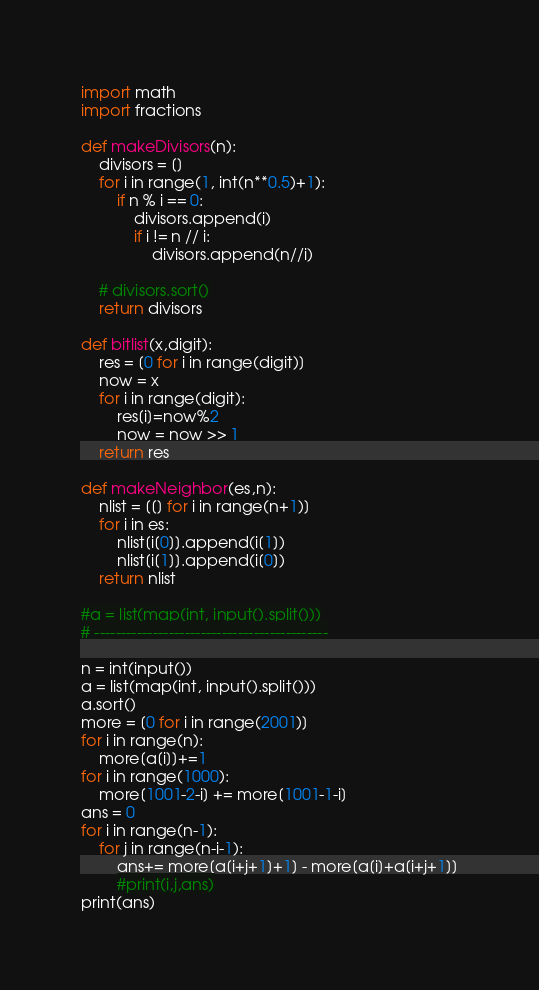<code> <loc_0><loc_0><loc_500><loc_500><_Python_>
import math
import fractions

def makeDivisors(n):
    divisors = []
    for i in range(1, int(n**0.5)+1):
        if n % i == 0:
            divisors.append(i)
            if i != n // i:
                divisors.append(n//i)

    # divisors.sort()
    return divisors

def bitlist(x,digit):
    res = [0 for i in range(digit)]
    now = x
    for i in range(digit):
        res[i]=now%2
        now = now >> 1
    return res

def makeNeighbor(es,n):
    nlist = [[] for i in range(n+1)]
    for i in es:
        nlist[i[0]].append(i[1])
        nlist[i[1]].append(i[0])
    return nlist
    
#a = list(map(int, input().split()))
# --------------------------------------------

n = int(input())
a = list(map(int, input().split()))
a.sort()
more = [0 for i in range(2001)]
for i in range(n):
    more[a[i]]+=1
for i in range(1000):
    more[1001-2-i] += more[1001-1-i]
ans = 0
for i in range(n-1):
    for j in range(n-i-1):
        ans+= more[a[i+j+1]+1] - more[a[i]+a[i+j+1]]
        #print(i,j,ans)
print(ans)</code> 